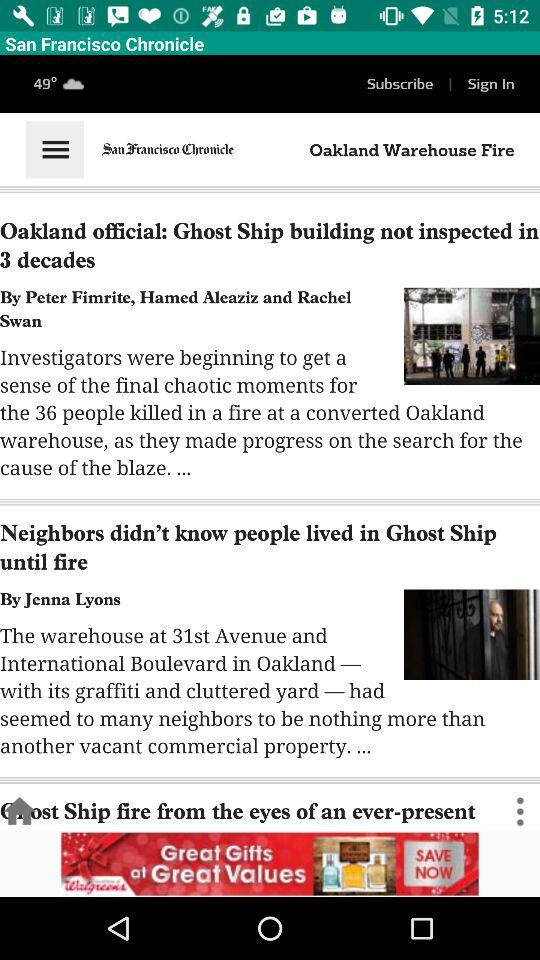Who's the author of "Neighbors didn't know people lived in Ghost Ship until fire"? The author of "Neighbors didn't know people lived in Ghost Ship until fire" is Jenna Lyons. 